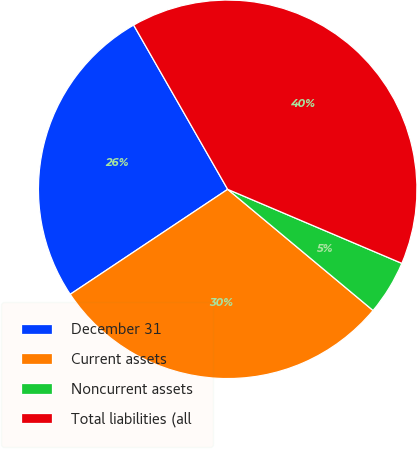Convert chart to OTSL. <chart><loc_0><loc_0><loc_500><loc_500><pie_chart><fcel>December 31<fcel>Current assets<fcel>Noncurrent assets<fcel>Total liabilities (all<nl><fcel>26.08%<fcel>29.58%<fcel>4.66%<fcel>39.67%<nl></chart> 